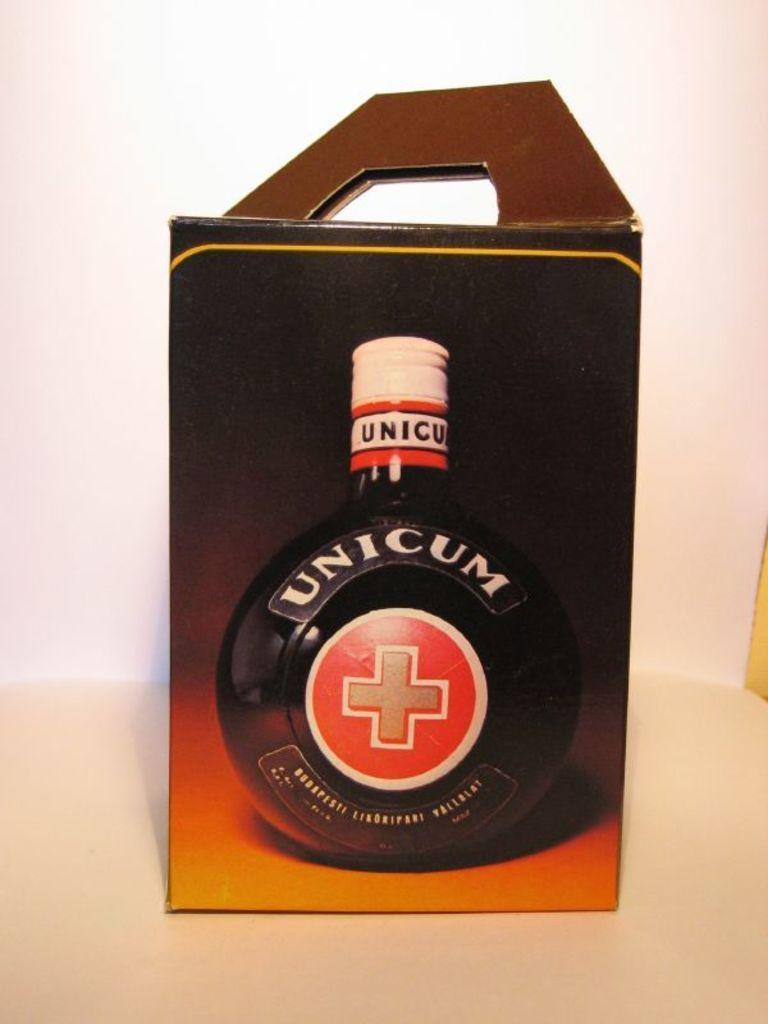Please provide a concise description of this image. In this picture we can see a box. On the box we can see picture of a bottle. There is a white background. 